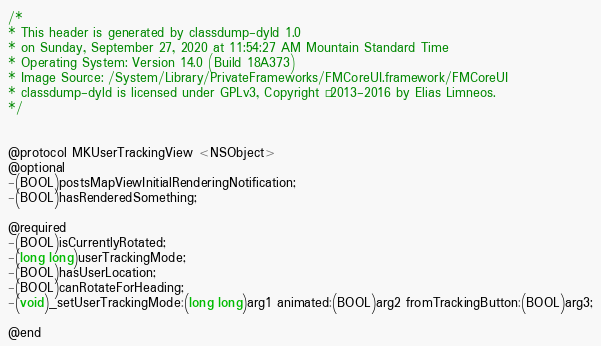Convert code to text. <code><loc_0><loc_0><loc_500><loc_500><_C_>/*
* This header is generated by classdump-dyld 1.0
* on Sunday, September 27, 2020 at 11:54:27 AM Mountain Standard Time
* Operating System: Version 14.0 (Build 18A373)
* Image Source: /System/Library/PrivateFrameworks/FMCoreUI.framework/FMCoreUI
* classdump-dyld is licensed under GPLv3, Copyright © 2013-2016 by Elias Limneos.
*/


@protocol MKUserTrackingView <NSObject>
@optional
-(BOOL)postsMapViewInitialRenderingNotification;
-(BOOL)hasRenderedSomething;

@required
-(BOOL)isCurrentlyRotated;
-(long long)userTrackingMode;
-(BOOL)hasUserLocation;
-(BOOL)canRotateForHeading;
-(void)_setUserTrackingMode:(long long)arg1 animated:(BOOL)arg2 fromTrackingButton:(BOOL)arg3;

@end

</code> 